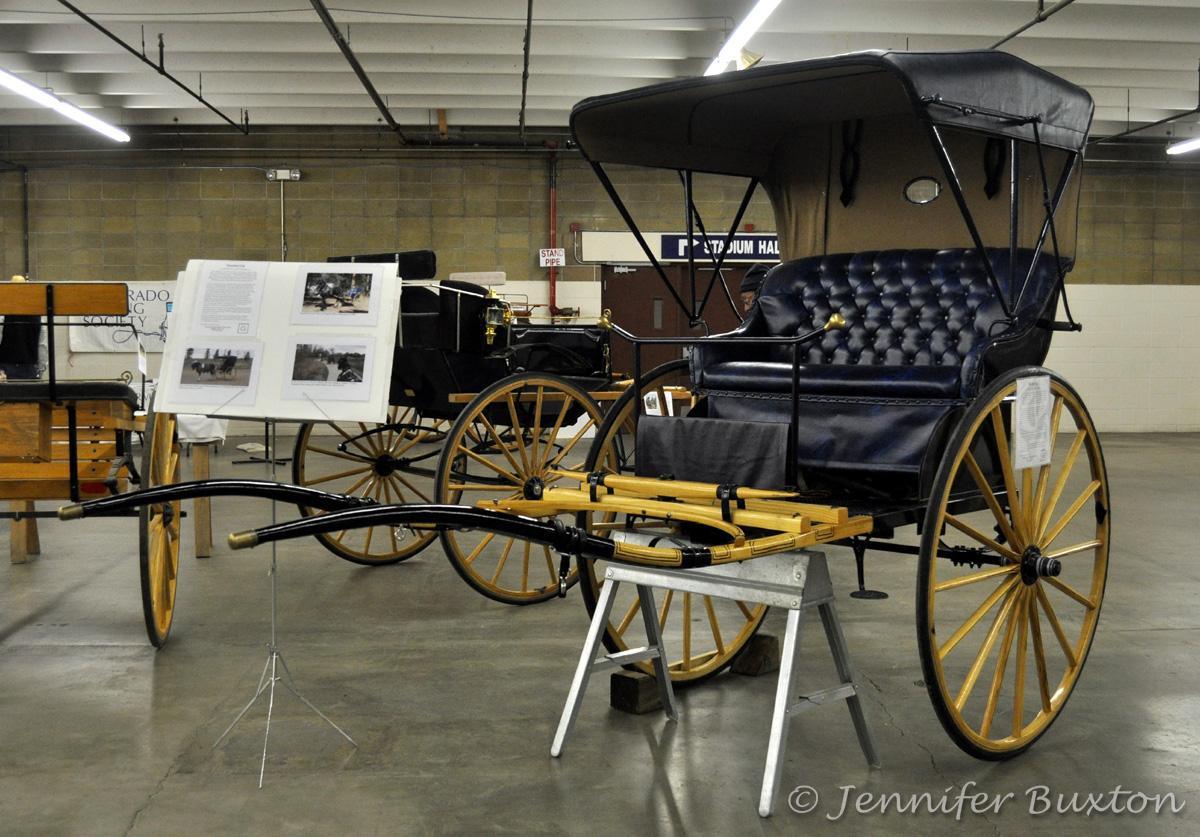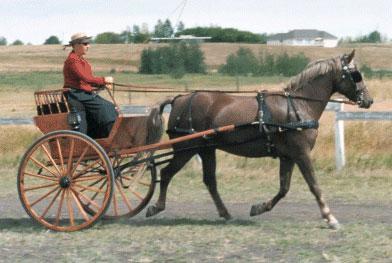The first image is the image on the left, the second image is the image on the right. Evaluate the accuracy of this statement regarding the images: "The carriage in the right image is covered.". Is it true? Answer yes or no. No. The first image is the image on the left, the second image is the image on the right. Analyze the images presented: Is the assertion "There is a total of two empty four wheel carts." valid? Answer yes or no. No. 